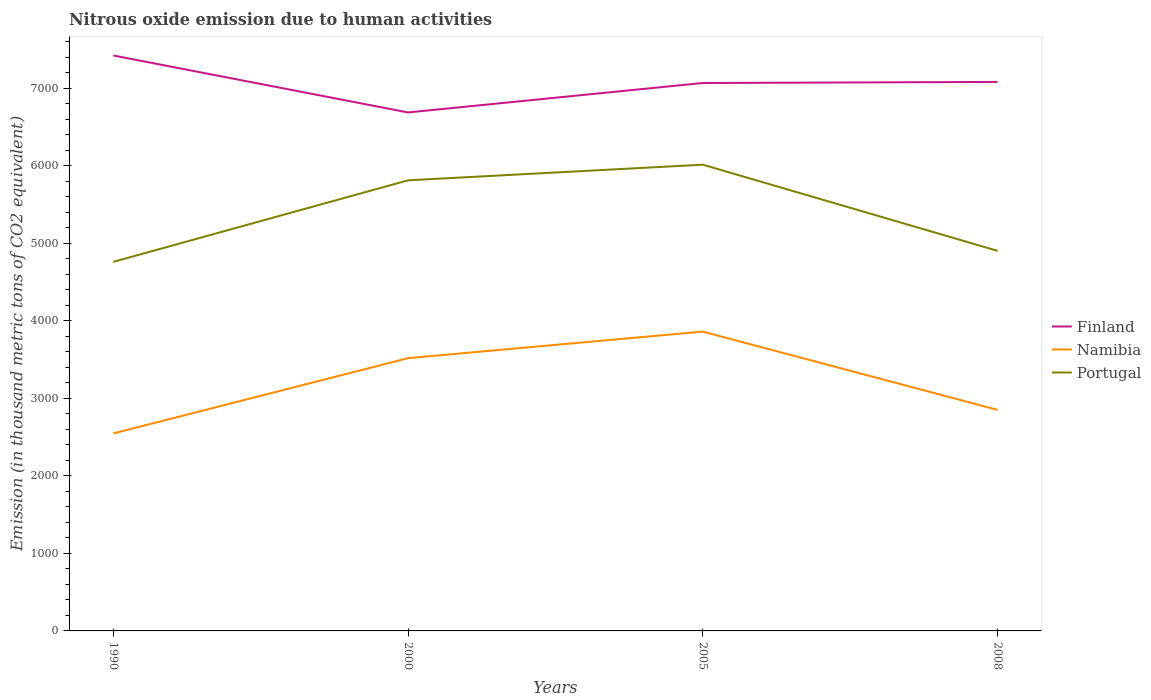Does the line corresponding to Namibia intersect with the line corresponding to Portugal?
Offer a terse response. No. Is the number of lines equal to the number of legend labels?
Provide a short and direct response. Yes. Across all years, what is the maximum amount of nitrous oxide emitted in Portugal?
Your answer should be compact. 4760.8. What is the total amount of nitrous oxide emitted in Namibia in the graph?
Ensure brevity in your answer.  -971.4. What is the difference between the highest and the second highest amount of nitrous oxide emitted in Portugal?
Your answer should be compact. 1253.4. Is the amount of nitrous oxide emitted in Namibia strictly greater than the amount of nitrous oxide emitted in Finland over the years?
Offer a terse response. Yes. How many lines are there?
Make the answer very short. 3. How many years are there in the graph?
Offer a very short reply. 4. What is the difference between two consecutive major ticks on the Y-axis?
Give a very brief answer. 1000. Are the values on the major ticks of Y-axis written in scientific E-notation?
Your answer should be compact. No. Does the graph contain any zero values?
Ensure brevity in your answer.  No. Where does the legend appear in the graph?
Ensure brevity in your answer.  Center right. How are the legend labels stacked?
Keep it short and to the point. Vertical. What is the title of the graph?
Provide a short and direct response. Nitrous oxide emission due to human activities. Does "Mongolia" appear as one of the legend labels in the graph?
Your answer should be very brief. No. What is the label or title of the X-axis?
Offer a very short reply. Years. What is the label or title of the Y-axis?
Offer a terse response. Emission (in thousand metric tons of CO2 equivalent). What is the Emission (in thousand metric tons of CO2 equivalent) of Finland in 1990?
Provide a short and direct response. 7423. What is the Emission (in thousand metric tons of CO2 equivalent) in Namibia in 1990?
Your answer should be very brief. 2547.1. What is the Emission (in thousand metric tons of CO2 equivalent) of Portugal in 1990?
Keep it short and to the point. 4760.8. What is the Emission (in thousand metric tons of CO2 equivalent) in Finland in 2000?
Offer a very short reply. 6688.1. What is the Emission (in thousand metric tons of CO2 equivalent) of Namibia in 2000?
Your response must be concise. 3518.5. What is the Emission (in thousand metric tons of CO2 equivalent) in Portugal in 2000?
Provide a short and direct response. 5812.6. What is the Emission (in thousand metric tons of CO2 equivalent) in Finland in 2005?
Provide a succinct answer. 7068. What is the Emission (in thousand metric tons of CO2 equivalent) of Namibia in 2005?
Offer a terse response. 3861.2. What is the Emission (in thousand metric tons of CO2 equivalent) in Portugal in 2005?
Your response must be concise. 6014.2. What is the Emission (in thousand metric tons of CO2 equivalent) of Finland in 2008?
Make the answer very short. 7081.9. What is the Emission (in thousand metric tons of CO2 equivalent) of Namibia in 2008?
Provide a succinct answer. 2851.2. What is the Emission (in thousand metric tons of CO2 equivalent) of Portugal in 2008?
Give a very brief answer. 4902.8. Across all years, what is the maximum Emission (in thousand metric tons of CO2 equivalent) of Finland?
Provide a succinct answer. 7423. Across all years, what is the maximum Emission (in thousand metric tons of CO2 equivalent) of Namibia?
Provide a succinct answer. 3861.2. Across all years, what is the maximum Emission (in thousand metric tons of CO2 equivalent) in Portugal?
Ensure brevity in your answer.  6014.2. Across all years, what is the minimum Emission (in thousand metric tons of CO2 equivalent) of Finland?
Ensure brevity in your answer.  6688.1. Across all years, what is the minimum Emission (in thousand metric tons of CO2 equivalent) in Namibia?
Your answer should be very brief. 2547.1. Across all years, what is the minimum Emission (in thousand metric tons of CO2 equivalent) of Portugal?
Your answer should be very brief. 4760.8. What is the total Emission (in thousand metric tons of CO2 equivalent) in Finland in the graph?
Provide a short and direct response. 2.83e+04. What is the total Emission (in thousand metric tons of CO2 equivalent) of Namibia in the graph?
Make the answer very short. 1.28e+04. What is the total Emission (in thousand metric tons of CO2 equivalent) of Portugal in the graph?
Your response must be concise. 2.15e+04. What is the difference between the Emission (in thousand metric tons of CO2 equivalent) of Finland in 1990 and that in 2000?
Provide a short and direct response. 734.9. What is the difference between the Emission (in thousand metric tons of CO2 equivalent) in Namibia in 1990 and that in 2000?
Ensure brevity in your answer.  -971.4. What is the difference between the Emission (in thousand metric tons of CO2 equivalent) in Portugal in 1990 and that in 2000?
Your answer should be compact. -1051.8. What is the difference between the Emission (in thousand metric tons of CO2 equivalent) in Finland in 1990 and that in 2005?
Keep it short and to the point. 355. What is the difference between the Emission (in thousand metric tons of CO2 equivalent) of Namibia in 1990 and that in 2005?
Provide a short and direct response. -1314.1. What is the difference between the Emission (in thousand metric tons of CO2 equivalent) of Portugal in 1990 and that in 2005?
Provide a succinct answer. -1253.4. What is the difference between the Emission (in thousand metric tons of CO2 equivalent) in Finland in 1990 and that in 2008?
Offer a very short reply. 341.1. What is the difference between the Emission (in thousand metric tons of CO2 equivalent) of Namibia in 1990 and that in 2008?
Keep it short and to the point. -304.1. What is the difference between the Emission (in thousand metric tons of CO2 equivalent) of Portugal in 1990 and that in 2008?
Give a very brief answer. -142. What is the difference between the Emission (in thousand metric tons of CO2 equivalent) of Finland in 2000 and that in 2005?
Ensure brevity in your answer.  -379.9. What is the difference between the Emission (in thousand metric tons of CO2 equivalent) of Namibia in 2000 and that in 2005?
Your answer should be very brief. -342.7. What is the difference between the Emission (in thousand metric tons of CO2 equivalent) of Portugal in 2000 and that in 2005?
Make the answer very short. -201.6. What is the difference between the Emission (in thousand metric tons of CO2 equivalent) in Finland in 2000 and that in 2008?
Keep it short and to the point. -393.8. What is the difference between the Emission (in thousand metric tons of CO2 equivalent) of Namibia in 2000 and that in 2008?
Ensure brevity in your answer.  667.3. What is the difference between the Emission (in thousand metric tons of CO2 equivalent) of Portugal in 2000 and that in 2008?
Your answer should be compact. 909.8. What is the difference between the Emission (in thousand metric tons of CO2 equivalent) of Finland in 2005 and that in 2008?
Offer a very short reply. -13.9. What is the difference between the Emission (in thousand metric tons of CO2 equivalent) of Namibia in 2005 and that in 2008?
Provide a succinct answer. 1010. What is the difference between the Emission (in thousand metric tons of CO2 equivalent) in Portugal in 2005 and that in 2008?
Ensure brevity in your answer.  1111.4. What is the difference between the Emission (in thousand metric tons of CO2 equivalent) of Finland in 1990 and the Emission (in thousand metric tons of CO2 equivalent) of Namibia in 2000?
Provide a short and direct response. 3904.5. What is the difference between the Emission (in thousand metric tons of CO2 equivalent) in Finland in 1990 and the Emission (in thousand metric tons of CO2 equivalent) in Portugal in 2000?
Your answer should be compact. 1610.4. What is the difference between the Emission (in thousand metric tons of CO2 equivalent) of Namibia in 1990 and the Emission (in thousand metric tons of CO2 equivalent) of Portugal in 2000?
Your response must be concise. -3265.5. What is the difference between the Emission (in thousand metric tons of CO2 equivalent) of Finland in 1990 and the Emission (in thousand metric tons of CO2 equivalent) of Namibia in 2005?
Keep it short and to the point. 3561.8. What is the difference between the Emission (in thousand metric tons of CO2 equivalent) of Finland in 1990 and the Emission (in thousand metric tons of CO2 equivalent) of Portugal in 2005?
Offer a very short reply. 1408.8. What is the difference between the Emission (in thousand metric tons of CO2 equivalent) of Namibia in 1990 and the Emission (in thousand metric tons of CO2 equivalent) of Portugal in 2005?
Provide a succinct answer. -3467.1. What is the difference between the Emission (in thousand metric tons of CO2 equivalent) in Finland in 1990 and the Emission (in thousand metric tons of CO2 equivalent) in Namibia in 2008?
Your answer should be compact. 4571.8. What is the difference between the Emission (in thousand metric tons of CO2 equivalent) in Finland in 1990 and the Emission (in thousand metric tons of CO2 equivalent) in Portugal in 2008?
Keep it short and to the point. 2520.2. What is the difference between the Emission (in thousand metric tons of CO2 equivalent) of Namibia in 1990 and the Emission (in thousand metric tons of CO2 equivalent) of Portugal in 2008?
Ensure brevity in your answer.  -2355.7. What is the difference between the Emission (in thousand metric tons of CO2 equivalent) in Finland in 2000 and the Emission (in thousand metric tons of CO2 equivalent) in Namibia in 2005?
Ensure brevity in your answer.  2826.9. What is the difference between the Emission (in thousand metric tons of CO2 equivalent) of Finland in 2000 and the Emission (in thousand metric tons of CO2 equivalent) of Portugal in 2005?
Provide a succinct answer. 673.9. What is the difference between the Emission (in thousand metric tons of CO2 equivalent) of Namibia in 2000 and the Emission (in thousand metric tons of CO2 equivalent) of Portugal in 2005?
Keep it short and to the point. -2495.7. What is the difference between the Emission (in thousand metric tons of CO2 equivalent) in Finland in 2000 and the Emission (in thousand metric tons of CO2 equivalent) in Namibia in 2008?
Keep it short and to the point. 3836.9. What is the difference between the Emission (in thousand metric tons of CO2 equivalent) in Finland in 2000 and the Emission (in thousand metric tons of CO2 equivalent) in Portugal in 2008?
Your answer should be compact. 1785.3. What is the difference between the Emission (in thousand metric tons of CO2 equivalent) of Namibia in 2000 and the Emission (in thousand metric tons of CO2 equivalent) of Portugal in 2008?
Give a very brief answer. -1384.3. What is the difference between the Emission (in thousand metric tons of CO2 equivalent) of Finland in 2005 and the Emission (in thousand metric tons of CO2 equivalent) of Namibia in 2008?
Provide a succinct answer. 4216.8. What is the difference between the Emission (in thousand metric tons of CO2 equivalent) of Finland in 2005 and the Emission (in thousand metric tons of CO2 equivalent) of Portugal in 2008?
Provide a short and direct response. 2165.2. What is the difference between the Emission (in thousand metric tons of CO2 equivalent) in Namibia in 2005 and the Emission (in thousand metric tons of CO2 equivalent) in Portugal in 2008?
Provide a succinct answer. -1041.6. What is the average Emission (in thousand metric tons of CO2 equivalent) in Finland per year?
Your answer should be compact. 7065.25. What is the average Emission (in thousand metric tons of CO2 equivalent) of Namibia per year?
Your response must be concise. 3194.5. What is the average Emission (in thousand metric tons of CO2 equivalent) of Portugal per year?
Make the answer very short. 5372.6. In the year 1990, what is the difference between the Emission (in thousand metric tons of CO2 equivalent) in Finland and Emission (in thousand metric tons of CO2 equivalent) in Namibia?
Your answer should be compact. 4875.9. In the year 1990, what is the difference between the Emission (in thousand metric tons of CO2 equivalent) in Finland and Emission (in thousand metric tons of CO2 equivalent) in Portugal?
Offer a very short reply. 2662.2. In the year 1990, what is the difference between the Emission (in thousand metric tons of CO2 equivalent) of Namibia and Emission (in thousand metric tons of CO2 equivalent) of Portugal?
Give a very brief answer. -2213.7. In the year 2000, what is the difference between the Emission (in thousand metric tons of CO2 equivalent) of Finland and Emission (in thousand metric tons of CO2 equivalent) of Namibia?
Your response must be concise. 3169.6. In the year 2000, what is the difference between the Emission (in thousand metric tons of CO2 equivalent) in Finland and Emission (in thousand metric tons of CO2 equivalent) in Portugal?
Give a very brief answer. 875.5. In the year 2000, what is the difference between the Emission (in thousand metric tons of CO2 equivalent) in Namibia and Emission (in thousand metric tons of CO2 equivalent) in Portugal?
Offer a terse response. -2294.1. In the year 2005, what is the difference between the Emission (in thousand metric tons of CO2 equivalent) in Finland and Emission (in thousand metric tons of CO2 equivalent) in Namibia?
Make the answer very short. 3206.8. In the year 2005, what is the difference between the Emission (in thousand metric tons of CO2 equivalent) in Finland and Emission (in thousand metric tons of CO2 equivalent) in Portugal?
Your answer should be very brief. 1053.8. In the year 2005, what is the difference between the Emission (in thousand metric tons of CO2 equivalent) of Namibia and Emission (in thousand metric tons of CO2 equivalent) of Portugal?
Your answer should be compact. -2153. In the year 2008, what is the difference between the Emission (in thousand metric tons of CO2 equivalent) in Finland and Emission (in thousand metric tons of CO2 equivalent) in Namibia?
Give a very brief answer. 4230.7. In the year 2008, what is the difference between the Emission (in thousand metric tons of CO2 equivalent) in Finland and Emission (in thousand metric tons of CO2 equivalent) in Portugal?
Provide a succinct answer. 2179.1. In the year 2008, what is the difference between the Emission (in thousand metric tons of CO2 equivalent) in Namibia and Emission (in thousand metric tons of CO2 equivalent) in Portugal?
Give a very brief answer. -2051.6. What is the ratio of the Emission (in thousand metric tons of CO2 equivalent) of Finland in 1990 to that in 2000?
Provide a short and direct response. 1.11. What is the ratio of the Emission (in thousand metric tons of CO2 equivalent) of Namibia in 1990 to that in 2000?
Ensure brevity in your answer.  0.72. What is the ratio of the Emission (in thousand metric tons of CO2 equivalent) in Portugal in 1990 to that in 2000?
Provide a short and direct response. 0.82. What is the ratio of the Emission (in thousand metric tons of CO2 equivalent) of Finland in 1990 to that in 2005?
Your answer should be very brief. 1.05. What is the ratio of the Emission (in thousand metric tons of CO2 equivalent) of Namibia in 1990 to that in 2005?
Your response must be concise. 0.66. What is the ratio of the Emission (in thousand metric tons of CO2 equivalent) of Portugal in 1990 to that in 2005?
Your response must be concise. 0.79. What is the ratio of the Emission (in thousand metric tons of CO2 equivalent) of Finland in 1990 to that in 2008?
Make the answer very short. 1.05. What is the ratio of the Emission (in thousand metric tons of CO2 equivalent) of Namibia in 1990 to that in 2008?
Provide a short and direct response. 0.89. What is the ratio of the Emission (in thousand metric tons of CO2 equivalent) in Finland in 2000 to that in 2005?
Offer a very short reply. 0.95. What is the ratio of the Emission (in thousand metric tons of CO2 equivalent) of Namibia in 2000 to that in 2005?
Keep it short and to the point. 0.91. What is the ratio of the Emission (in thousand metric tons of CO2 equivalent) of Portugal in 2000 to that in 2005?
Keep it short and to the point. 0.97. What is the ratio of the Emission (in thousand metric tons of CO2 equivalent) of Namibia in 2000 to that in 2008?
Offer a terse response. 1.23. What is the ratio of the Emission (in thousand metric tons of CO2 equivalent) in Portugal in 2000 to that in 2008?
Offer a very short reply. 1.19. What is the ratio of the Emission (in thousand metric tons of CO2 equivalent) of Finland in 2005 to that in 2008?
Offer a very short reply. 1. What is the ratio of the Emission (in thousand metric tons of CO2 equivalent) in Namibia in 2005 to that in 2008?
Provide a short and direct response. 1.35. What is the ratio of the Emission (in thousand metric tons of CO2 equivalent) of Portugal in 2005 to that in 2008?
Provide a succinct answer. 1.23. What is the difference between the highest and the second highest Emission (in thousand metric tons of CO2 equivalent) in Finland?
Offer a very short reply. 341.1. What is the difference between the highest and the second highest Emission (in thousand metric tons of CO2 equivalent) of Namibia?
Make the answer very short. 342.7. What is the difference between the highest and the second highest Emission (in thousand metric tons of CO2 equivalent) in Portugal?
Offer a terse response. 201.6. What is the difference between the highest and the lowest Emission (in thousand metric tons of CO2 equivalent) of Finland?
Offer a terse response. 734.9. What is the difference between the highest and the lowest Emission (in thousand metric tons of CO2 equivalent) of Namibia?
Offer a terse response. 1314.1. What is the difference between the highest and the lowest Emission (in thousand metric tons of CO2 equivalent) of Portugal?
Provide a succinct answer. 1253.4. 